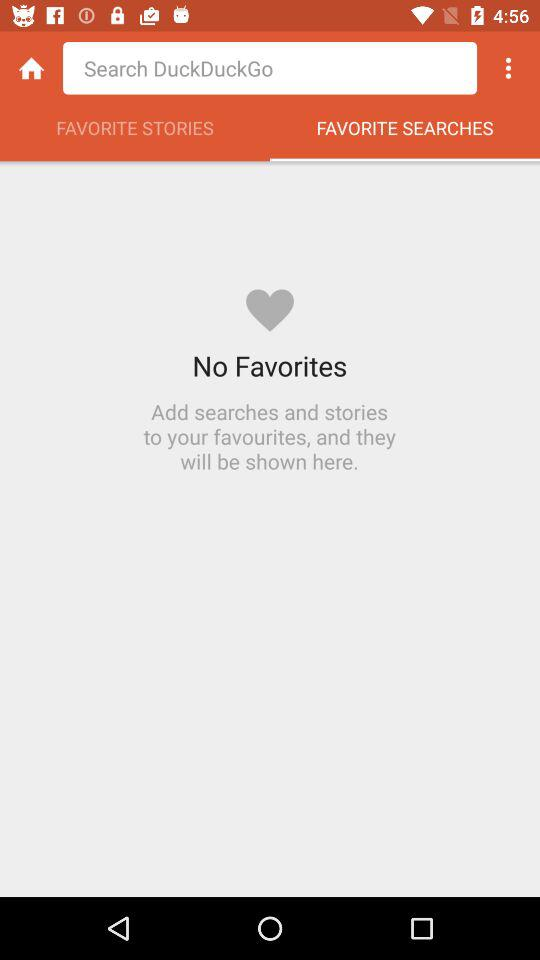Which tab is selected? The selected tab is "FAVORITE SEARCHES". 